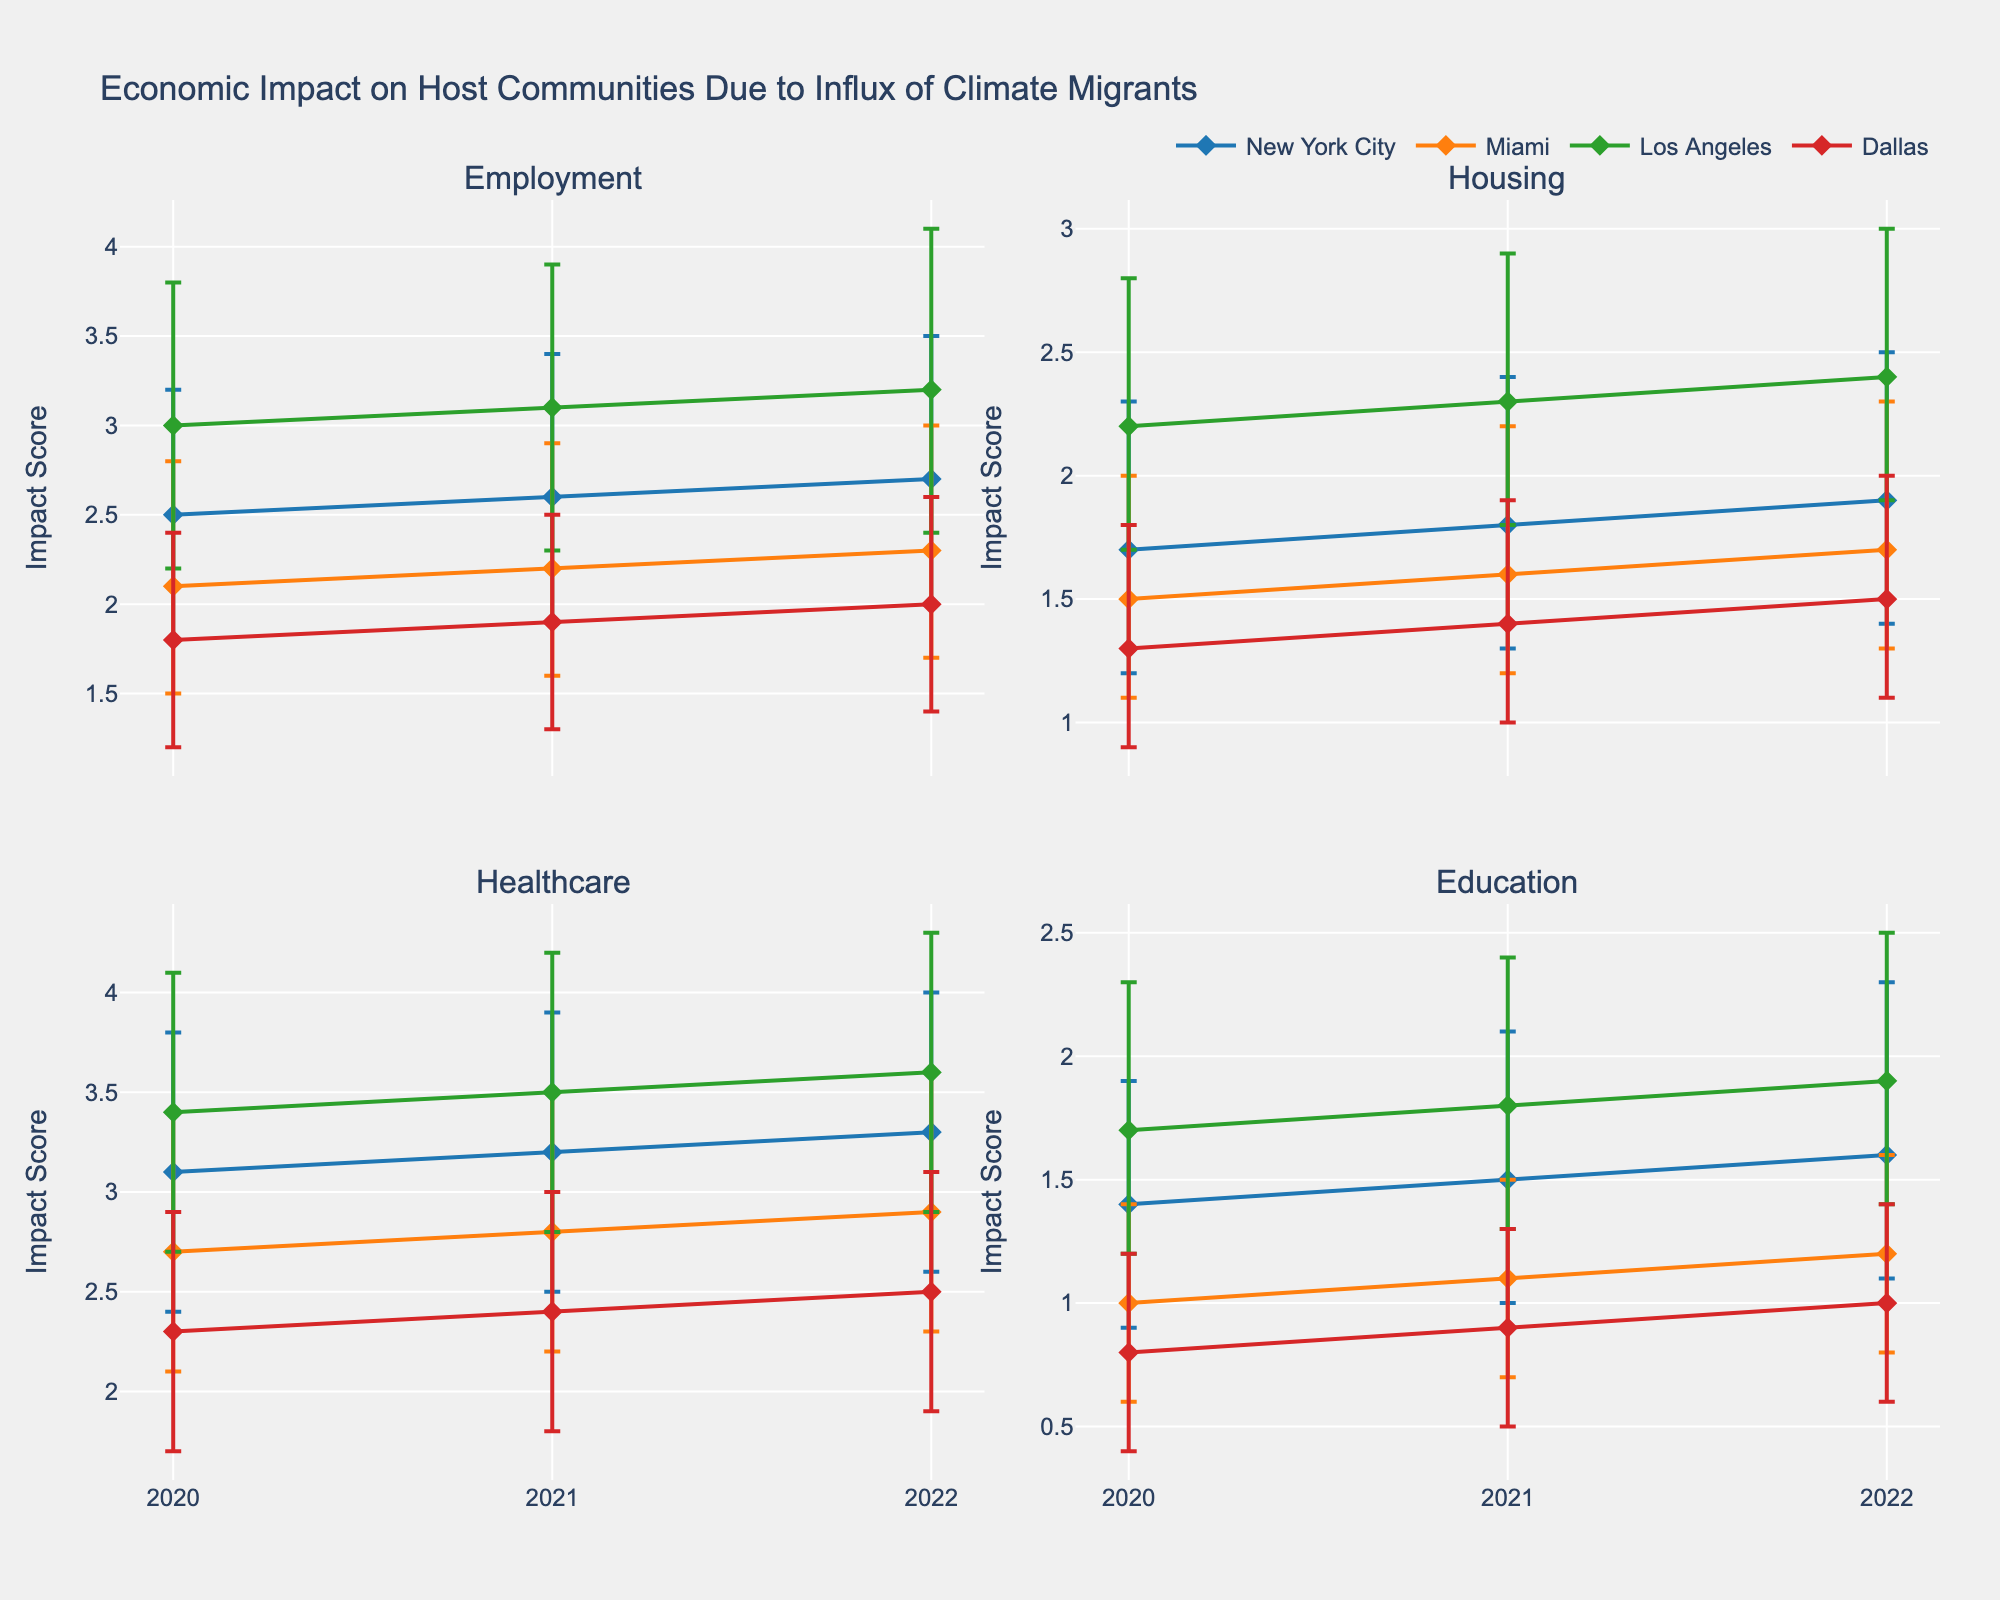What is the overall title of the figure? The title of the figure is displayed prominently at the top of the figure and provides a summary of what the figure contains. In this case, the title is "Economic Impact on Host Communities Due to Influx of Climate Migrants".
Answer: Economic Impact on Host Communities Due to Influx of Climate Migrants Which host community shows the highest Employment Impact Mean for the year 2022? Look at the subplot for Employment Impact and find the data points for the year 2022. The highest Employment Impact Mean is for Los Angeles, which in 2022 has an impact mean of 3.2.
Answer: Los Angeles What is the range of the Housing Impact for New York City in 2020? Find the Housing Impact subplot and look for New York City in the year 2020. The range is determined by the lower and upper bounds: 1.2 (lower) and 2.3 (upper).
Answer: [1.2, 2.3] In which category does Miami show the least impact in 2020? Observe all four subplots for the year 2020 and compare Miami’s impact values. The least impact for Miami in 2020 is in the Education category, where the mean is 1.0.
Answer: Education How does the Healthcare Impact for Dallas change from 2020 to 2022? In the Healthcare Impact subplot, compare the data points for Dallas from 2020 to 2022. In 2020, the mean impact is 2.3, and in 2022, it is 2.5. Hence, the Healthcare Impact increases.
Answer: Increases What are the upper and lower bounds of the Education Impact for Los Angeles in 2021? Locate the Education Impact subplot and find the data for Los Angeles in 2021. The upper bound is 2.4, and the lower bound is 1.3.
Answer: Upper: 2.4, Lower: 1.3 Which host community has the largest error bars in Healthcare Impact in 2020? In the Healthcare Impact subplot, review the error bars for each host community in 2020. Los Angeles has the largest error bars with an upper bound of 4.1 and a lower bound of 2.7.
Answer: Los Angeles Which host community has the smallest increase in Employment Impact Mean from 2020 to 2022? Compare the Employment Impact Means of all host communities from 2020 to 2022. Dallas has the smallest increase, from 1.8 in 2020 to 2.0 in 2022.
Answer: Dallas Which impact type shows the most variability for New York City across the years 2020 to 2022? Evaluate all impact types for New York City by comparing the error bars over the years. Healthcare has the most variability with the largest differences between upper and lower bounds.
Answer: Healthcare 